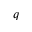<formula> <loc_0><loc_0><loc_500><loc_500>q</formula> 